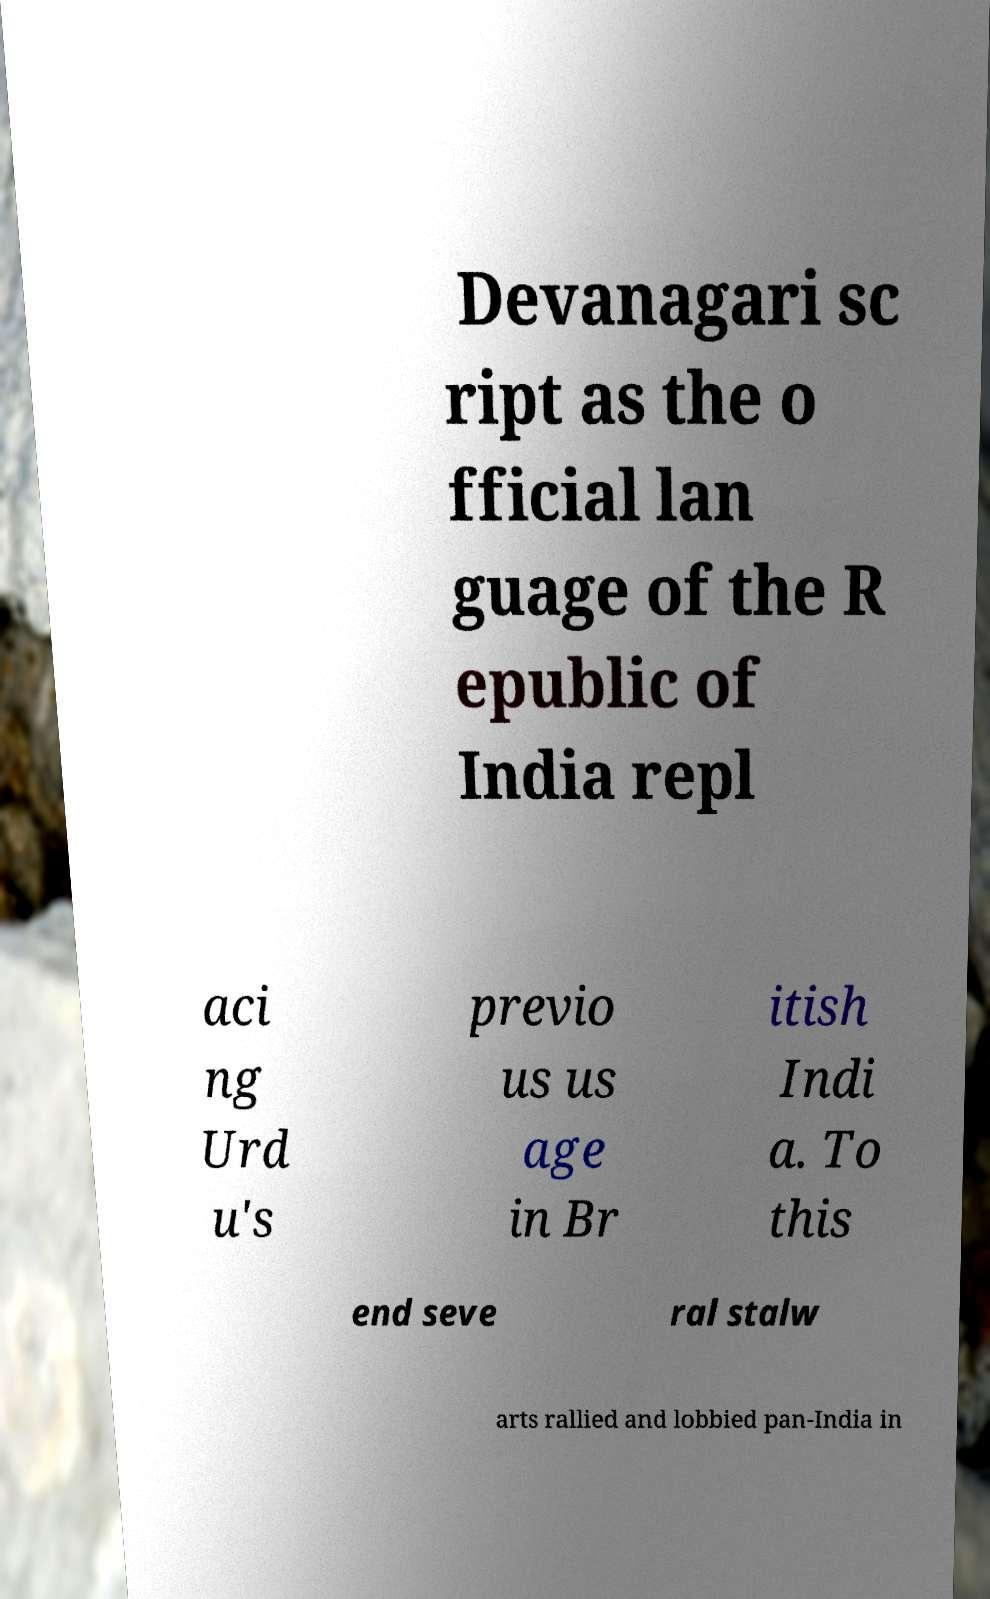Please identify and transcribe the text found in this image. Devanagari sc ript as the o fficial lan guage of the R epublic of India repl aci ng Urd u's previo us us age in Br itish Indi a. To this end seve ral stalw arts rallied and lobbied pan-India in 